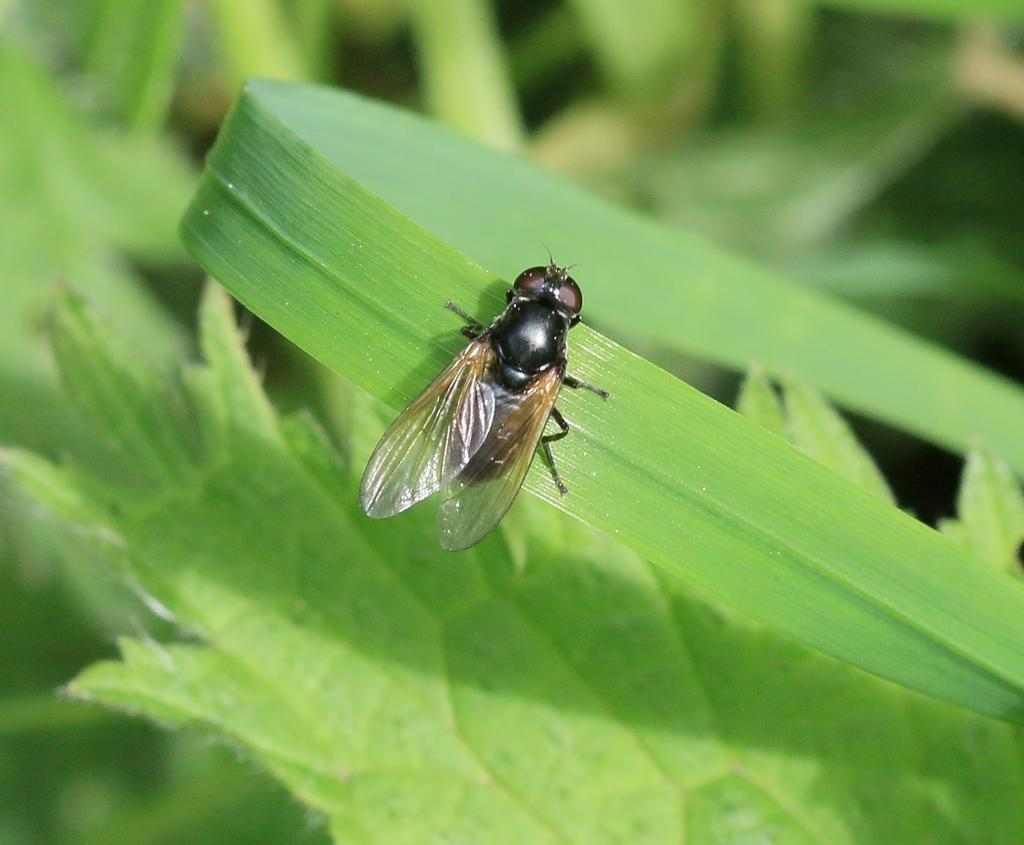What is on the leaf in the image? There is a fly on a leaf in the image. What can be seen in the background of the image? There are leaves visible in the background of the image. What theory does the stranger present in the image? There is no stranger or theory present in the image; it only features a fly on a leaf and leaves in the background. 